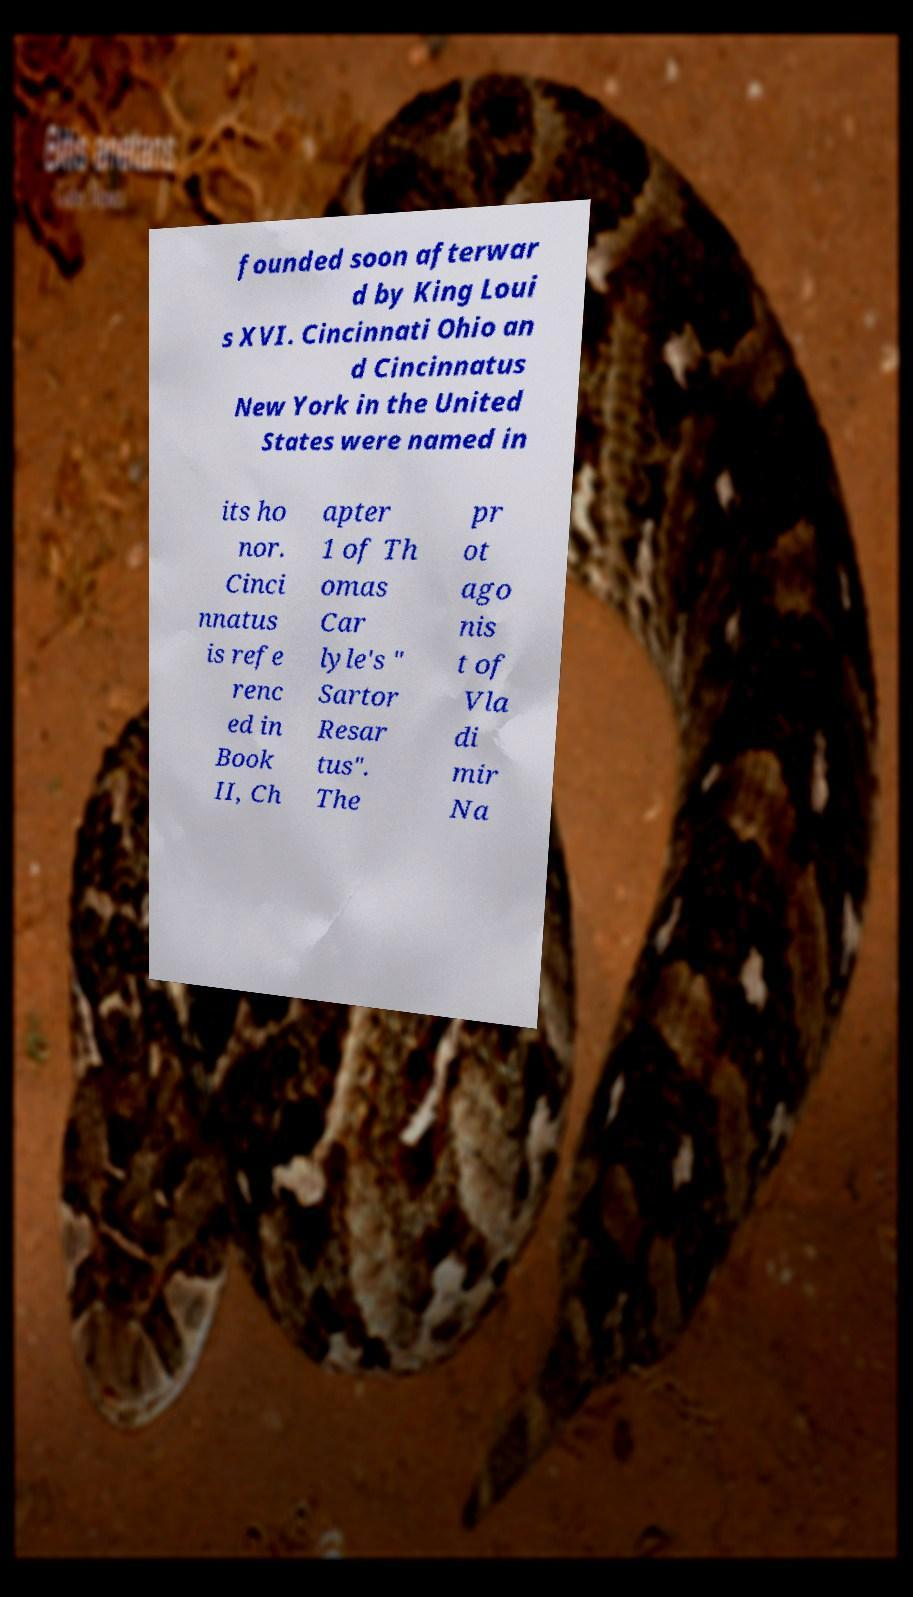I need the written content from this picture converted into text. Can you do that? founded soon afterwar d by King Loui s XVI. Cincinnati Ohio an d Cincinnatus New York in the United States were named in its ho nor. Cinci nnatus is refe renc ed in Book II, Ch apter 1 of Th omas Car lyle's " Sartor Resar tus". The pr ot ago nis t of Vla di mir Na 